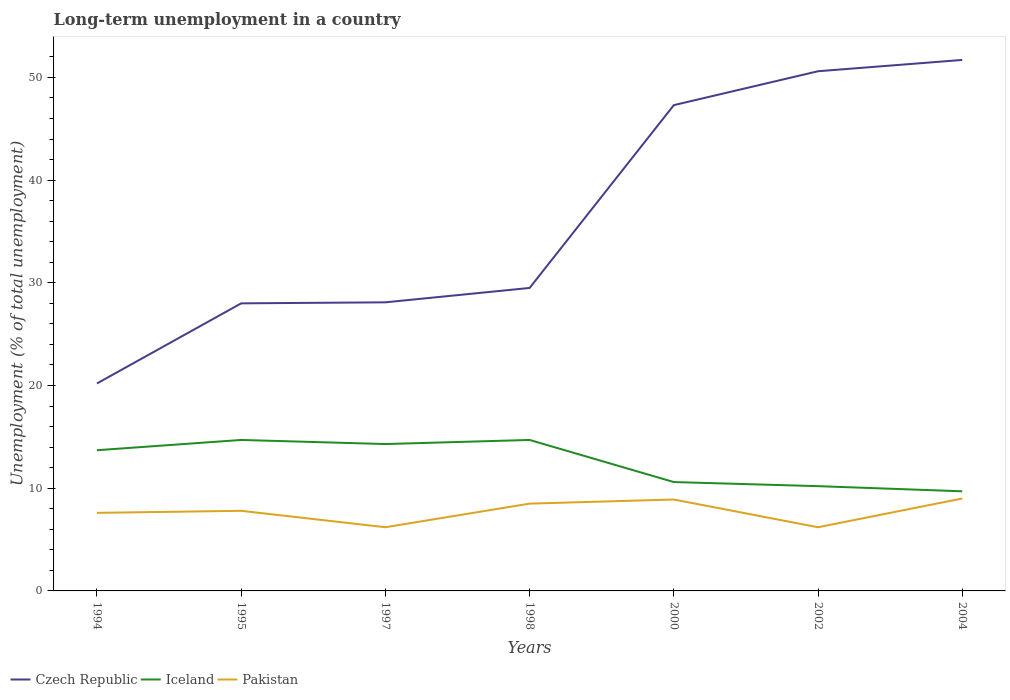How many different coloured lines are there?
Your answer should be very brief. 3. Is the number of lines equal to the number of legend labels?
Keep it short and to the point. Yes. Across all years, what is the maximum percentage of long-term unemployed population in Czech Republic?
Offer a very short reply. 20.2. What is the total percentage of long-term unemployed population in Czech Republic in the graph?
Your answer should be very brief. -7.8. What is the difference between the highest and the second highest percentage of long-term unemployed population in Iceland?
Offer a very short reply. 5. What is the difference between the highest and the lowest percentage of long-term unemployed population in Iceland?
Keep it short and to the point. 4. Are the values on the major ticks of Y-axis written in scientific E-notation?
Ensure brevity in your answer.  No. Does the graph contain any zero values?
Provide a short and direct response. No. What is the title of the graph?
Provide a short and direct response. Long-term unemployment in a country. Does "Sweden" appear as one of the legend labels in the graph?
Your response must be concise. No. What is the label or title of the Y-axis?
Your answer should be very brief. Unemployment (% of total unemployment). What is the Unemployment (% of total unemployment) in Czech Republic in 1994?
Offer a very short reply. 20.2. What is the Unemployment (% of total unemployment) of Iceland in 1994?
Provide a succinct answer. 13.7. What is the Unemployment (% of total unemployment) in Pakistan in 1994?
Your response must be concise. 7.6. What is the Unemployment (% of total unemployment) of Czech Republic in 1995?
Offer a terse response. 28. What is the Unemployment (% of total unemployment) of Iceland in 1995?
Provide a short and direct response. 14.7. What is the Unemployment (% of total unemployment) in Pakistan in 1995?
Offer a terse response. 7.8. What is the Unemployment (% of total unemployment) in Czech Republic in 1997?
Give a very brief answer. 28.1. What is the Unemployment (% of total unemployment) of Iceland in 1997?
Offer a terse response. 14.3. What is the Unemployment (% of total unemployment) of Pakistan in 1997?
Provide a short and direct response. 6.2. What is the Unemployment (% of total unemployment) in Czech Republic in 1998?
Your answer should be very brief. 29.5. What is the Unemployment (% of total unemployment) in Iceland in 1998?
Your response must be concise. 14.7. What is the Unemployment (% of total unemployment) in Czech Republic in 2000?
Provide a short and direct response. 47.3. What is the Unemployment (% of total unemployment) in Iceland in 2000?
Provide a succinct answer. 10.6. What is the Unemployment (% of total unemployment) in Pakistan in 2000?
Your response must be concise. 8.9. What is the Unemployment (% of total unemployment) of Czech Republic in 2002?
Ensure brevity in your answer.  50.6. What is the Unemployment (% of total unemployment) of Iceland in 2002?
Make the answer very short. 10.2. What is the Unemployment (% of total unemployment) in Pakistan in 2002?
Give a very brief answer. 6.2. What is the Unemployment (% of total unemployment) of Czech Republic in 2004?
Make the answer very short. 51.7. What is the Unemployment (% of total unemployment) in Iceland in 2004?
Offer a terse response. 9.7. What is the Unemployment (% of total unemployment) of Pakistan in 2004?
Offer a very short reply. 9. Across all years, what is the maximum Unemployment (% of total unemployment) of Czech Republic?
Your response must be concise. 51.7. Across all years, what is the maximum Unemployment (% of total unemployment) of Iceland?
Provide a succinct answer. 14.7. Across all years, what is the maximum Unemployment (% of total unemployment) in Pakistan?
Your answer should be very brief. 9. Across all years, what is the minimum Unemployment (% of total unemployment) of Czech Republic?
Your answer should be compact. 20.2. Across all years, what is the minimum Unemployment (% of total unemployment) in Iceland?
Make the answer very short. 9.7. Across all years, what is the minimum Unemployment (% of total unemployment) in Pakistan?
Make the answer very short. 6.2. What is the total Unemployment (% of total unemployment) in Czech Republic in the graph?
Make the answer very short. 255.4. What is the total Unemployment (% of total unemployment) in Iceland in the graph?
Offer a terse response. 87.9. What is the total Unemployment (% of total unemployment) in Pakistan in the graph?
Your answer should be very brief. 54.2. What is the difference between the Unemployment (% of total unemployment) in Czech Republic in 1994 and that in 1995?
Provide a short and direct response. -7.8. What is the difference between the Unemployment (% of total unemployment) of Iceland in 1994 and that in 1998?
Give a very brief answer. -1. What is the difference between the Unemployment (% of total unemployment) in Czech Republic in 1994 and that in 2000?
Give a very brief answer. -27.1. What is the difference between the Unemployment (% of total unemployment) of Czech Republic in 1994 and that in 2002?
Your answer should be compact. -30.4. What is the difference between the Unemployment (% of total unemployment) in Pakistan in 1994 and that in 2002?
Provide a succinct answer. 1.4. What is the difference between the Unemployment (% of total unemployment) in Czech Republic in 1994 and that in 2004?
Provide a succinct answer. -31.5. What is the difference between the Unemployment (% of total unemployment) of Pakistan in 1994 and that in 2004?
Offer a terse response. -1.4. What is the difference between the Unemployment (% of total unemployment) of Iceland in 1995 and that in 1997?
Provide a succinct answer. 0.4. What is the difference between the Unemployment (% of total unemployment) in Czech Republic in 1995 and that in 2000?
Provide a succinct answer. -19.3. What is the difference between the Unemployment (% of total unemployment) of Iceland in 1995 and that in 2000?
Ensure brevity in your answer.  4.1. What is the difference between the Unemployment (% of total unemployment) of Pakistan in 1995 and that in 2000?
Provide a succinct answer. -1.1. What is the difference between the Unemployment (% of total unemployment) of Czech Republic in 1995 and that in 2002?
Your response must be concise. -22.6. What is the difference between the Unemployment (% of total unemployment) in Pakistan in 1995 and that in 2002?
Provide a short and direct response. 1.6. What is the difference between the Unemployment (% of total unemployment) in Czech Republic in 1995 and that in 2004?
Your answer should be compact. -23.7. What is the difference between the Unemployment (% of total unemployment) in Iceland in 1995 and that in 2004?
Your answer should be very brief. 5. What is the difference between the Unemployment (% of total unemployment) of Iceland in 1997 and that in 1998?
Offer a terse response. -0.4. What is the difference between the Unemployment (% of total unemployment) of Czech Republic in 1997 and that in 2000?
Ensure brevity in your answer.  -19.2. What is the difference between the Unemployment (% of total unemployment) of Pakistan in 1997 and that in 2000?
Keep it short and to the point. -2.7. What is the difference between the Unemployment (% of total unemployment) in Czech Republic in 1997 and that in 2002?
Offer a terse response. -22.5. What is the difference between the Unemployment (% of total unemployment) of Czech Republic in 1997 and that in 2004?
Ensure brevity in your answer.  -23.6. What is the difference between the Unemployment (% of total unemployment) in Iceland in 1997 and that in 2004?
Keep it short and to the point. 4.6. What is the difference between the Unemployment (% of total unemployment) of Czech Republic in 1998 and that in 2000?
Offer a very short reply. -17.8. What is the difference between the Unemployment (% of total unemployment) of Czech Republic in 1998 and that in 2002?
Your answer should be compact. -21.1. What is the difference between the Unemployment (% of total unemployment) of Iceland in 1998 and that in 2002?
Ensure brevity in your answer.  4.5. What is the difference between the Unemployment (% of total unemployment) of Pakistan in 1998 and that in 2002?
Your response must be concise. 2.3. What is the difference between the Unemployment (% of total unemployment) in Czech Republic in 1998 and that in 2004?
Make the answer very short. -22.2. What is the difference between the Unemployment (% of total unemployment) in Pakistan in 1998 and that in 2004?
Offer a very short reply. -0.5. What is the difference between the Unemployment (% of total unemployment) in Iceland in 2000 and that in 2002?
Make the answer very short. 0.4. What is the difference between the Unemployment (% of total unemployment) in Pakistan in 2000 and that in 2004?
Keep it short and to the point. -0.1. What is the difference between the Unemployment (% of total unemployment) of Iceland in 2002 and that in 2004?
Keep it short and to the point. 0.5. What is the difference between the Unemployment (% of total unemployment) in Pakistan in 2002 and that in 2004?
Provide a succinct answer. -2.8. What is the difference between the Unemployment (% of total unemployment) of Iceland in 1994 and the Unemployment (% of total unemployment) of Pakistan in 1995?
Offer a terse response. 5.9. What is the difference between the Unemployment (% of total unemployment) of Czech Republic in 1994 and the Unemployment (% of total unemployment) of Iceland in 1997?
Offer a very short reply. 5.9. What is the difference between the Unemployment (% of total unemployment) of Czech Republic in 1994 and the Unemployment (% of total unemployment) of Pakistan in 1997?
Your answer should be compact. 14. What is the difference between the Unemployment (% of total unemployment) of Iceland in 1994 and the Unemployment (% of total unemployment) of Pakistan in 1998?
Keep it short and to the point. 5.2. What is the difference between the Unemployment (% of total unemployment) in Czech Republic in 1994 and the Unemployment (% of total unemployment) in Pakistan in 2000?
Your answer should be very brief. 11.3. What is the difference between the Unemployment (% of total unemployment) of Iceland in 1994 and the Unemployment (% of total unemployment) of Pakistan in 2002?
Offer a very short reply. 7.5. What is the difference between the Unemployment (% of total unemployment) of Czech Republic in 1994 and the Unemployment (% of total unemployment) of Iceland in 2004?
Your answer should be compact. 10.5. What is the difference between the Unemployment (% of total unemployment) of Iceland in 1994 and the Unemployment (% of total unemployment) of Pakistan in 2004?
Your answer should be compact. 4.7. What is the difference between the Unemployment (% of total unemployment) of Czech Republic in 1995 and the Unemployment (% of total unemployment) of Pakistan in 1997?
Give a very brief answer. 21.8. What is the difference between the Unemployment (% of total unemployment) in Czech Republic in 1995 and the Unemployment (% of total unemployment) in Pakistan in 1998?
Your response must be concise. 19.5. What is the difference between the Unemployment (% of total unemployment) of Iceland in 1995 and the Unemployment (% of total unemployment) of Pakistan in 1998?
Provide a short and direct response. 6.2. What is the difference between the Unemployment (% of total unemployment) of Czech Republic in 1995 and the Unemployment (% of total unemployment) of Pakistan in 2000?
Your answer should be very brief. 19.1. What is the difference between the Unemployment (% of total unemployment) in Iceland in 1995 and the Unemployment (% of total unemployment) in Pakistan in 2000?
Offer a terse response. 5.8. What is the difference between the Unemployment (% of total unemployment) in Czech Republic in 1995 and the Unemployment (% of total unemployment) in Pakistan in 2002?
Provide a succinct answer. 21.8. What is the difference between the Unemployment (% of total unemployment) in Iceland in 1995 and the Unemployment (% of total unemployment) in Pakistan in 2002?
Make the answer very short. 8.5. What is the difference between the Unemployment (% of total unemployment) of Iceland in 1995 and the Unemployment (% of total unemployment) of Pakistan in 2004?
Keep it short and to the point. 5.7. What is the difference between the Unemployment (% of total unemployment) in Czech Republic in 1997 and the Unemployment (% of total unemployment) in Iceland in 1998?
Provide a succinct answer. 13.4. What is the difference between the Unemployment (% of total unemployment) in Czech Republic in 1997 and the Unemployment (% of total unemployment) in Pakistan in 1998?
Make the answer very short. 19.6. What is the difference between the Unemployment (% of total unemployment) in Iceland in 1997 and the Unemployment (% of total unemployment) in Pakistan in 1998?
Provide a succinct answer. 5.8. What is the difference between the Unemployment (% of total unemployment) of Czech Republic in 1997 and the Unemployment (% of total unemployment) of Iceland in 2000?
Ensure brevity in your answer.  17.5. What is the difference between the Unemployment (% of total unemployment) in Czech Republic in 1997 and the Unemployment (% of total unemployment) in Pakistan in 2000?
Ensure brevity in your answer.  19.2. What is the difference between the Unemployment (% of total unemployment) of Iceland in 1997 and the Unemployment (% of total unemployment) of Pakistan in 2000?
Ensure brevity in your answer.  5.4. What is the difference between the Unemployment (% of total unemployment) of Czech Republic in 1997 and the Unemployment (% of total unemployment) of Pakistan in 2002?
Your answer should be very brief. 21.9. What is the difference between the Unemployment (% of total unemployment) of Iceland in 1997 and the Unemployment (% of total unemployment) of Pakistan in 2002?
Your answer should be compact. 8.1. What is the difference between the Unemployment (% of total unemployment) in Iceland in 1997 and the Unemployment (% of total unemployment) in Pakistan in 2004?
Provide a short and direct response. 5.3. What is the difference between the Unemployment (% of total unemployment) in Czech Republic in 1998 and the Unemployment (% of total unemployment) in Pakistan in 2000?
Keep it short and to the point. 20.6. What is the difference between the Unemployment (% of total unemployment) in Czech Republic in 1998 and the Unemployment (% of total unemployment) in Iceland in 2002?
Your answer should be very brief. 19.3. What is the difference between the Unemployment (% of total unemployment) of Czech Republic in 1998 and the Unemployment (% of total unemployment) of Pakistan in 2002?
Offer a terse response. 23.3. What is the difference between the Unemployment (% of total unemployment) of Czech Republic in 1998 and the Unemployment (% of total unemployment) of Iceland in 2004?
Provide a short and direct response. 19.8. What is the difference between the Unemployment (% of total unemployment) of Iceland in 1998 and the Unemployment (% of total unemployment) of Pakistan in 2004?
Provide a succinct answer. 5.7. What is the difference between the Unemployment (% of total unemployment) in Czech Republic in 2000 and the Unemployment (% of total unemployment) in Iceland in 2002?
Ensure brevity in your answer.  37.1. What is the difference between the Unemployment (% of total unemployment) of Czech Republic in 2000 and the Unemployment (% of total unemployment) of Pakistan in 2002?
Provide a succinct answer. 41.1. What is the difference between the Unemployment (% of total unemployment) of Iceland in 2000 and the Unemployment (% of total unemployment) of Pakistan in 2002?
Make the answer very short. 4.4. What is the difference between the Unemployment (% of total unemployment) in Czech Republic in 2000 and the Unemployment (% of total unemployment) in Iceland in 2004?
Give a very brief answer. 37.6. What is the difference between the Unemployment (% of total unemployment) of Czech Republic in 2000 and the Unemployment (% of total unemployment) of Pakistan in 2004?
Your answer should be compact. 38.3. What is the difference between the Unemployment (% of total unemployment) in Czech Republic in 2002 and the Unemployment (% of total unemployment) in Iceland in 2004?
Ensure brevity in your answer.  40.9. What is the difference between the Unemployment (% of total unemployment) of Czech Republic in 2002 and the Unemployment (% of total unemployment) of Pakistan in 2004?
Offer a terse response. 41.6. What is the average Unemployment (% of total unemployment) of Czech Republic per year?
Provide a short and direct response. 36.49. What is the average Unemployment (% of total unemployment) of Iceland per year?
Give a very brief answer. 12.56. What is the average Unemployment (% of total unemployment) of Pakistan per year?
Make the answer very short. 7.74. In the year 1994, what is the difference between the Unemployment (% of total unemployment) in Czech Republic and Unemployment (% of total unemployment) in Pakistan?
Provide a succinct answer. 12.6. In the year 1995, what is the difference between the Unemployment (% of total unemployment) of Czech Republic and Unemployment (% of total unemployment) of Pakistan?
Your response must be concise. 20.2. In the year 1995, what is the difference between the Unemployment (% of total unemployment) of Iceland and Unemployment (% of total unemployment) of Pakistan?
Your answer should be compact. 6.9. In the year 1997, what is the difference between the Unemployment (% of total unemployment) in Czech Republic and Unemployment (% of total unemployment) in Iceland?
Your answer should be very brief. 13.8. In the year 1997, what is the difference between the Unemployment (% of total unemployment) in Czech Republic and Unemployment (% of total unemployment) in Pakistan?
Ensure brevity in your answer.  21.9. In the year 1997, what is the difference between the Unemployment (% of total unemployment) in Iceland and Unemployment (% of total unemployment) in Pakistan?
Provide a succinct answer. 8.1. In the year 1998, what is the difference between the Unemployment (% of total unemployment) in Czech Republic and Unemployment (% of total unemployment) in Iceland?
Give a very brief answer. 14.8. In the year 1998, what is the difference between the Unemployment (% of total unemployment) in Czech Republic and Unemployment (% of total unemployment) in Pakistan?
Offer a very short reply. 21. In the year 1998, what is the difference between the Unemployment (% of total unemployment) in Iceland and Unemployment (% of total unemployment) in Pakistan?
Give a very brief answer. 6.2. In the year 2000, what is the difference between the Unemployment (% of total unemployment) of Czech Republic and Unemployment (% of total unemployment) of Iceland?
Keep it short and to the point. 36.7. In the year 2000, what is the difference between the Unemployment (% of total unemployment) of Czech Republic and Unemployment (% of total unemployment) of Pakistan?
Offer a terse response. 38.4. In the year 2002, what is the difference between the Unemployment (% of total unemployment) of Czech Republic and Unemployment (% of total unemployment) of Iceland?
Provide a short and direct response. 40.4. In the year 2002, what is the difference between the Unemployment (% of total unemployment) of Czech Republic and Unemployment (% of total unemployment) of Pakistan?
Provide a short and direct response. 44.4. In the year 2002, what is the difference between the Unemployment (% of total unemployment) in Iceland and Unemployment (% of total unemployment) in Pakistan?
Keep it short and to the point. 4. In the year 2004, what is the difference between the Unemployment (% of total unemployment) in Czech Republic and Unemployment (% of total unemployment) in Pakistan?
Provide a succinct answer. 42.7. What is the ratio of the Unemployment (% of total unemployment) in Czech Republic in 1994 to that in 1995?
Your response must be concise. 0.72. What is the ratio of the Unemployment (% of total unemployment) in Iceland in 1994 to that in 1995?
Provide a succinct answer. 0.93. What is the ratio of the Unemployment (% of total unemployment) of Pakistan in 1994 to that in 1995?
Keep it short and to the point. 0.97. What is the ratio of the Unemployment (% of total unemployment) in Czech Republic in 1994 to that in 1997?
Ensure brevity in your answer.  0.72. What is the ratio of the Unemployment (% of total unemployment) of Iceland in 1994 to that in 1997?
Make the answer very short. 0.96. What is the ratio of the Unemployment (% of total unemployment) of Pakistan in 1994 to that in 1997?
Provide a succinct answer. 1.23. What is the ratio of the Unemployment (% of total unemployment) in Czech Republic in 1994 to that in 1998?
Offer a very short reply. 0.68. What is the ratio of the Unemployment (% of total unemployment) in Iceland in 1994 to that in 1998?
Make the answer very short. 0.93. What is the ratio of the Unemployment (% of total unemployment) of Pakistan in 1994 to that in 1998?
Your answer should be very brief. 0.89. What is the ratio of the Unemployment (% of total unemployment) of Czech Republic in 1994 to that in 2000?
Offer a terse response. 0.43. What is the ratio of the Unemployment (% of total unemployment) of Iceland in 1994 to that in 2000?
Provide a succinct answer. 1.29. What is the ratio of the Unemployment (% of total unemployment) of Pakistan in 1994 to that in 2000?
Give a very brief answer. 0.85. What is the ratio of the Unemployment (% of total unemployment) in Czech Republic in 1994 to that in 2002?
Keep it short and to the point. 0.4. What is the ratio of the Unemployment (% of total unemployment) of Iceland in 1994 to that in 2002?
Your response must be concise. 1.34. What is the ratio of the Unemployment (% of total unemployment) of Pakistan in 1994 to that in 2002?
Provide a short and direct response. 1.23. What is the ratio of the Unemployment (% of total unemployment) of Czech Republic in 1994 to that in 2004?
Your answer should be very brief. 0.39. What is the ratio of the Unemployment (% of total unemployment) in Iceland in 1994 to that in 2004?
Your answer should be very brief. 1.41. What is the ratio of the Unemployment (% of total unemployment) in Pakistan in 1994 to that in 2004?
Give a very brief answer. 0.84. What is the ratio of the Unemployment (% of total unemployment) in Czech Republic in 1995 to that in 1997?
Make the answer very short. 1. What is the ratio of the Unemployment (% of total unemployment) of Iceland in 1995 to that in 1997?
Keep it short and to the point. 1.03. What is the ratio of the Unemployment (% of total unemployment) in Pakistan in 1995 to that in 1997?
Offer a terse response. 1.26. What is the ratio of the Unemployment (% of total unemployment) in Czech Republic in 1995 to that in 1998?
Provide a short and direct response. 0.95. What is the ratio of the Unemployment (% of total unemployment) in Pakistan in 1995 to that in 1998?
Offer a very short reply. 0.92. What is the ratio of the Unemployment (% of total unemployment) in Czech Republic in 1995 to that in 2000?
Keep it short and to the point. 0.59. What is the ratio of the Unemployment (% of total unemployment) in Iceland in 1995 to that in 2000?
Your answer should be very brief. 1.39. What is the ratio of the Unemployment (% of total unemployment) in Pakistan in 1995 to that in 2000?
Give a very brief answer. 0.88. What is the ratio of the Unemployment (% of total unemployment) in Czech Republic in 1995 to that in 2002?
Your answer should be very brief. 0.55. What is the ratio of the Unemployment (% of total unemployment) in Iceland in 1995 to that in 2002?
Your answer should be very brief. 1.44. What is the ratio of the Unemployment (% of total unemployment) in Pakistan in 1995 to that in 2002?
Your answer should be very brief. 1.26. What is the ratio of the Unemployment (% of total unemployment) of Czech Republic in 1995 to that in 2004?
Make the answer very short. 0.54. What is the ratio of the Unemployment (% of total unemployment) of Iceland in 1995 to that in 2004?
Offer a very short reply. 1.52. What is the ratio of the Unemployment (% of total unemployment) of Pakistan in 1995 to that in 2004?
Make the answer very short. 0.87. What is the ratio of the Unemployment (% of total unemployment) in Czech Republic in 1997 to that in 1998?
Make the answer very short. 0.95. What is the ratio of the Unemployment (% of total unemployment) of Iceland in 1997 to that in 1998?
Provide a short and direct response. 0.97. What is the ratio of the Unemployment (% of total unemployment) in Pakistan in 1997 to that in 1998?
Make the answer very short. 0.73. What is the ratio of the Unemployment (% of total unemployment) in Czech Republic in 1997 to that in 2000?
Make the answer very short. 0.59. What is the ratio of the Unemployment (% of total unemployment) of Iceland in 1997 to that in 2000?
Your answer should be very brief. 1.35. What is the ratio of the Unemployment (% of total unemployment) of Pakistan in 1997 to that in 2000?
Give a very brief answer. 0.7. What is the ratio of the Unemployment (% of total unemployment) of Czech Republic in 1997 to that in 2002?
Provide a succinct answer. 0.56. What is the ratio of the Unemployment (% of total unemployment) of Iceland in 1997 to that in 2002?
Your answer should be compact. 1.4. What is the ratio of the Unemployment (% of total unemployment) of Czech Republic in 1997 to that in 2004?
Your answer should be compact. 0.54. What is the ratio of the Unemployment (% of total unemployment) in Iceland in 1997 to that in 2004?
Make the answer very short. 1.47. What is the ratio of the Unemployment (% of total unemployment) of Pakistan in 1997 to that in 2004?
Keep it short and to the point. 0.69. What is the ratio of the Unemployment (% of total unemployment) in Czech Republic in 1998 to that in 2000?
Offer a very short reply. 0.62. What is the ratio of the Unemployment (% of total unemployment) in Iceland in 1998 to that in 2000?
Give a very brief answer. 1.39. What is the ratio of the Unemployment (% of total unemployment) of Pakistan in 1998 to that in 2000?
Provide a succinct answer. 0.96. What is the ratio of the Unemployment (% of total unemployment) in Czech Republic in 1998 to that in 2002?
Your answer should be compact. 0.58. What is the ratio of the Unemployment (% of total unemployment) in Iceland in 1998 to that in 2002?
Ensure brevity in your answer.  1.44. What is the ratio of the Unemployment (% of total unemployment) in Pakistan in 1998 to that in 2002?
Offer a very short reply. 1.37. What is the ratio of the Unemployment (% of total unemployment) of Czech Republic in 1998 to that in 2004?
Your answer should be compact. 0.57. What is the ratio of the Unemployment (% of total unemployment) in Iceland in 1998 to that in 2004?
Provide a succinct answer. 1.52. What is the ratio of the Unemployment (% of total unemployment) of Pakistan in 1998 to that in 2004?
Your answer should be compact. 0.94. What is the ratio of the Unemployment (% of total unemployment) of Czech Republic in 2000 to that in 2002?
Your response must be concise. 0.93. What is the ratio of the Unemployment (% of total unemployment) of Iceland in 2000 to that in 2002?
Give a very brief answer. 1.04. What is the ratio of the Unemployment (% of total unemployment) in Pakistan in 2000 to that in 2002?
Keep it short and to the point. 1.44. What is the ratio of the Unemployment (% of total unemployment) of Czech Republic in 2000 to that in 2004?
Offer a very short reply. 0.91. What is the ratio of the Unemployment (% of total unemployment) of Iceland in 2000 to that in 2004?
Offer a terse response. 1.09. What is the ratio of the Unemployment (% of total unemployment) in Pakistan in 2000 to that in 2004?
Make the answer very short. 0.99. What is the ratio of the Unemployment (% of total unemployment) of Czech Republic in 2002 to that in 2004?
Your answer should be very brief. 0.98. What is the ratio of the Unemployment (% of total unemployment) of Iceland in 2002 to that in 2004?
Offer a very short reply. 1.05. What is the ratio of the Unemployment (% of total unemployment) of Pakistan in 2002 to that in 2004?
Your answer should be compact. 0.69. What is the difference between the highest and the second highest Unemployment (% of total unemployment) in Iceland?
Offer a terse response. 0. What is the difference between the highest and the lowest Unemployment (% of total unemployment) in Czech Republic?
Ensure brevity in your answer.  31.5. What is the difference between the highest and the lowest Unemployment (% of total unemployment) in Pakistan?
Offer a very short reply. 2.8. 